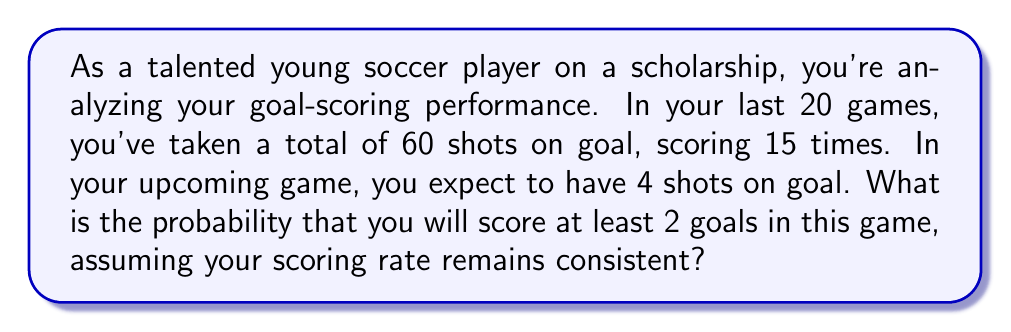Teach me how to tackle this problem. Let's approach this step-by-step using the binomial probability distribution:

1) First, calculate the probability of scoring on a single shot:
   $p = \frac{\text{goals scored}}{\text{total shots}} = \frac{15}{60} = 0.25$ or 25%

2) The probability of not scoring on a shot is:
   $q = 1 - p = 1 - 0.25 = 0.75$ or 75%

3) We want the probability of scoring at least 2 goals out of 4 shots. This is equivalent to the probability of scoring 2, 3, or 4 goals.

4) We can use the binomial probability formula:
   $P(X = k) = \binom{n}{k} p^k q^{n-k}$
   where $n$ is the number of trials (shots), $k$ is the number of successes (goals), $p$ is the probability of success on a single trial, and $q$ is the probability of failure on a single trial.

5) Calculate the probability for each case:

   For 2 goals: $P(X = 2) = \binom{4}{2} (0.25)^2 (0.75)^2 = 6 \cdot 0.0625 \cdot 0.5625 = 0.2109375$
   
   For 3 goals: $P(X = 3) = \binom{4}{3} (0.25)^3 (0.75)^1 = 4 \cdot 0.015625 \cdot 0.75 = 0.046875$
   
   For 4 goals: $P(X = 4) = \binom{4}{4} (0.25)^4 (0.75)^0 = 1 \cdot 0.00390625 \cdot 1 = 0.00390625$

6) Sum these probabilities:
   $P(X \geq 2) = P(X = 2) + P(X = 3) + P(X = 4)$
   $= 0.2109375 + 0.046875 + 0.00390625 = 0.26171875$

Thus, the probability of scoring at least 2 goals in the upcoming game is approximately 0.2617 or 26.17%.
Answer: The probability of scoring at least 2 goals in the upcoming game is approximately 0.2617 or 26.17%. 